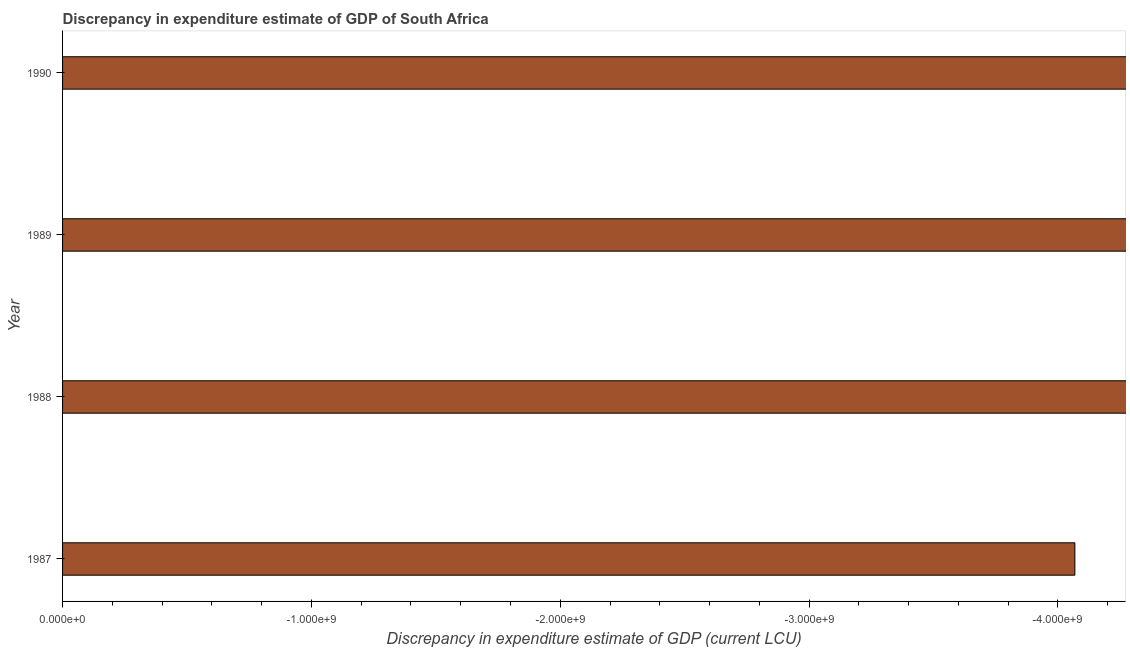Does the graph contain any zero values?
Offer a terse response. Yes. Does the graph contain grids?
Offer a terse response. No. What is the title of the graph?
Ensure brevity in your answer.  Discrepancy in expenditure estimate of GDP of South Africa. What is the label or title of the X-axis?
Ensure brevity in your answer.  Discrepancy in expenditure estimate of GDP (current LCU). What is the label or title of the Y-axis?
Your answer should be very brief. Year. What is the discrepancy in expenditure estimate of gdp in 1988?
Offer a terse response. 0. Across all years, what is the minimum discrepancy in expenditure estimate of gdp?
Your answer should be compact. 0. What is the sum of the discrepancy in expenditure estimate of gdp?
Provide a succinct answer. 0. What is the average discrepancy in expenditure estimate of gdp per year?
Your answer should be very brief. 0. How many bars are there?
Offer a terse response. 0. How many years are there in the graph?
Your answer should be very brief. 4. What is the Discrepancy in expenditure estimate of GDP (current LCU) of 1988?
Provide a succinct answer. 0. What is the Discrepancy in expenditure estimate of GDP (current LCU) in 1990?
Keep it short and to the point. 0. 